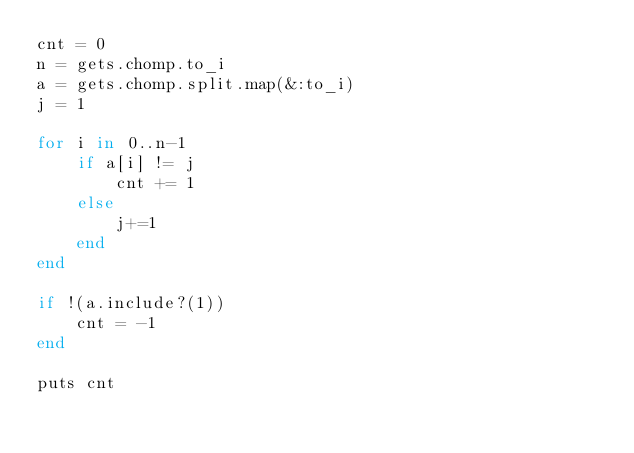Convert code to text. <code><loc_0><loc_0><loc_500><loc_500><_Ruby_>cnt = 0
n = gets.chomp.to_i
a = gets.chomp.split.map(&:to_i)
j = 1

for i in 0..n-1
    if a[i] != j
        cnt += 1
    else
        j+=1
    end
end

if !(a.include?(1))
    cnt = -1
end

puts cnt</code> 